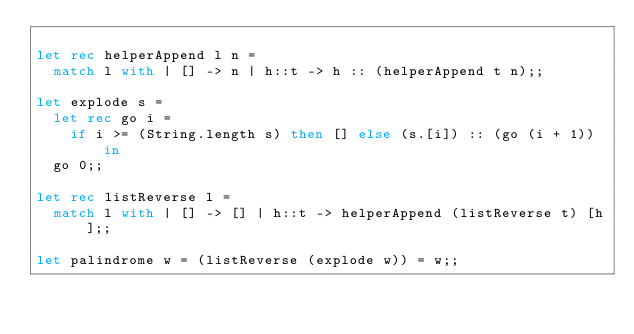Convert code to text. <code><loc_0><loc_0><loc_500><loc_500><_OCaml_>
let rec helperAppend l n =
  match l with | [] -> n | h::t -> h :: (helperAppend t n);;

let explode s =
  let rec go i =
    if i >= (String.length s) then [] else (s.[i]) :: (go (i + 1)) in
  go 0;;

let rec listReverse l =
  match l with | [] -> [] | h::t -> helperAppend (listReverse t) [h];;

let palindrome w = (listReverse (explode w)) = w;;
</code> 